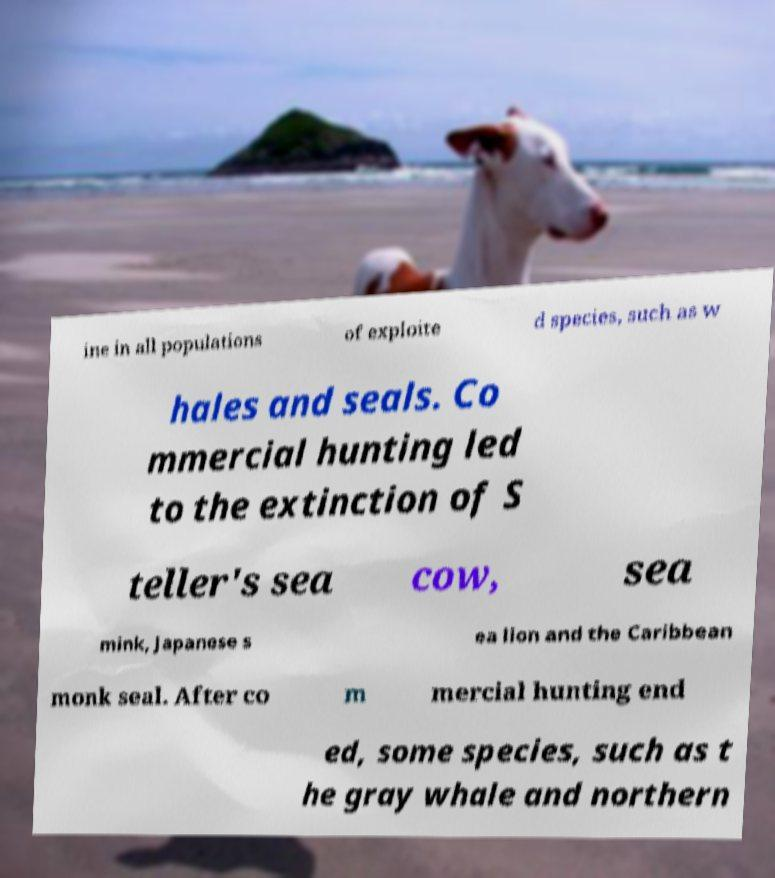Could you extract and type out the text from this image? ine in all populations of exploite d species, such as w hales and seals. Co mmercial hunting led to the extinction of S teller's sea cow, sea mink, Japanese s ea lion and the Caribbean monk seal. After co m mercial hunting end ed, some species, such as t he gray whale and northern 